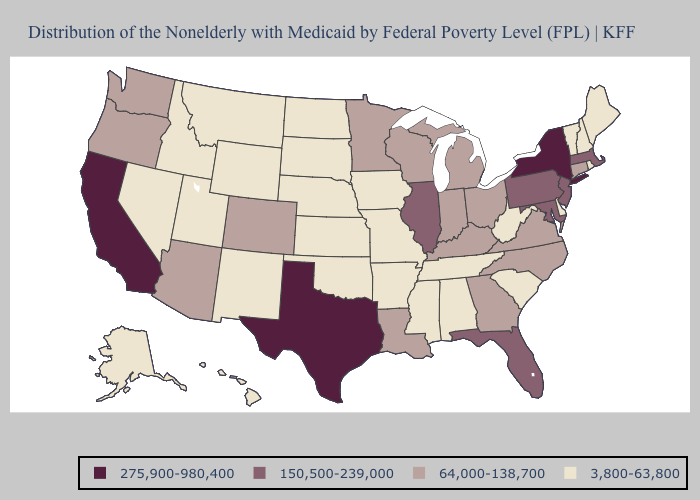Does Hawaii have a higher value than Minnesota?
Write a very short answer. No. Does Texas have the highest value in the USA?
Quick response, please. Yes. What is the value of North Dakota?
Be succinct. 3,800-63,800. What is the value of Oklahoma?
Short answer required. 3,800-63,800. Does Montana have the lowest value in the USA?
Quick response, please. Yes. What is the value of New Hampshire?
Be succinct. 3,800-63,800. What is the value of Texas?
Keep it brief. 275,900-980,400. Does Georgia have the highest value in the South?
Answer briefly. No. Name the states that have a value in the range 275,900-980,400?
Concise answer only. California, New York, Texas. Does the map have missing data?
Short answer required. No. Does Delaware have the same value as North Dakota?
Quick response, please. Yes. What is the value of Washington?
Keep it brief. 64,000-138,700. Among the states that border North Dakota , does Minnesota have the highest value?
Answer briefly. Yes. What is the highest value in the USA?
Concise answer only. 275,900-980,400. Name the states that have a value in the range 150,500-239,000?
Keep it brief. Florida, Illinois, Maryland, Massachusetts, New Jersey, Pennsylvania. 